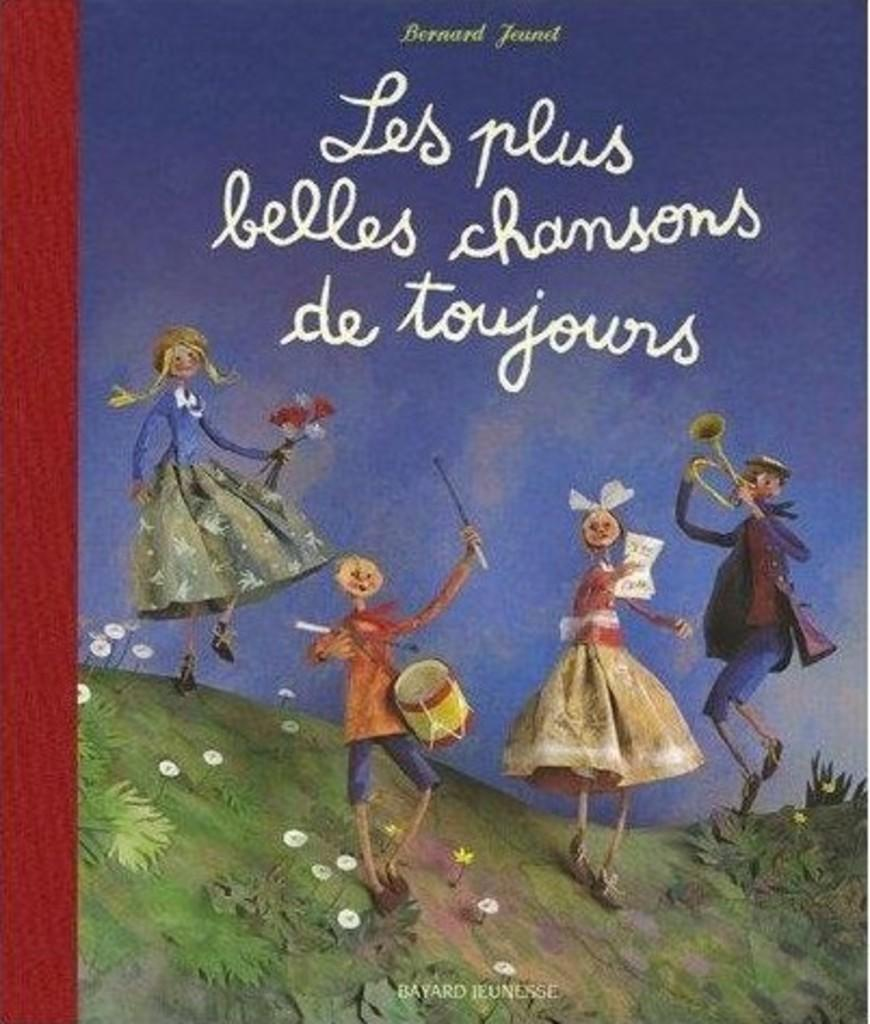What is the main subject of the image? There is a painting in the image. What can be seen on the painting? There is writing on the painting, and it depicts animated children. What are the children in the painting doing? Some of the children in the painting are holding musical instruments. What else is present in the painting? There are plants in the painting. What type of holiday is depicted in the painting? The image does not depict a holiday; it is a painting of animated children, some of whom are holding musical instruments and surrounded by plants. 